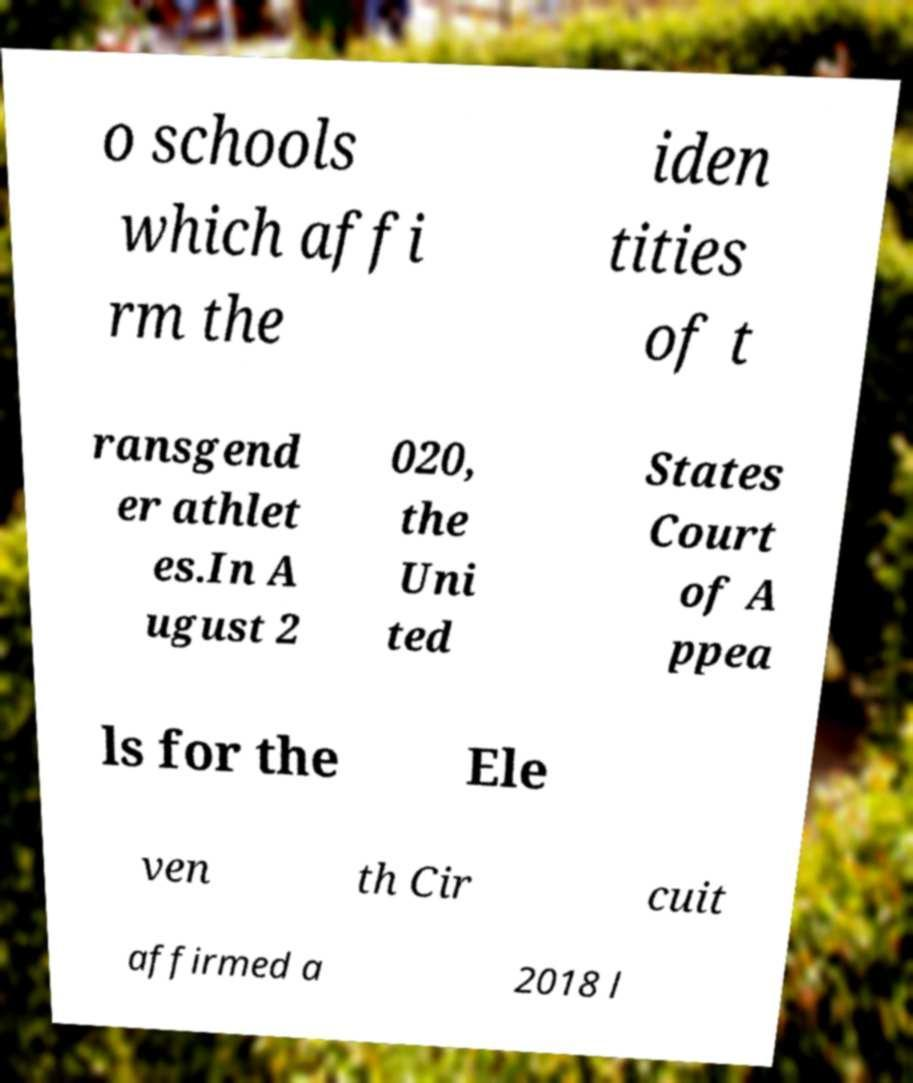For documentation purposes, I need the text within this image transcribed. Could you provide that? o schools which affi rm the iden tities of t ransgend er athlet es.In A ugust 2 020, the Uni ted States Court of A ppea ls for the Ele ven th Cir cuit affirmed a 2018 l 